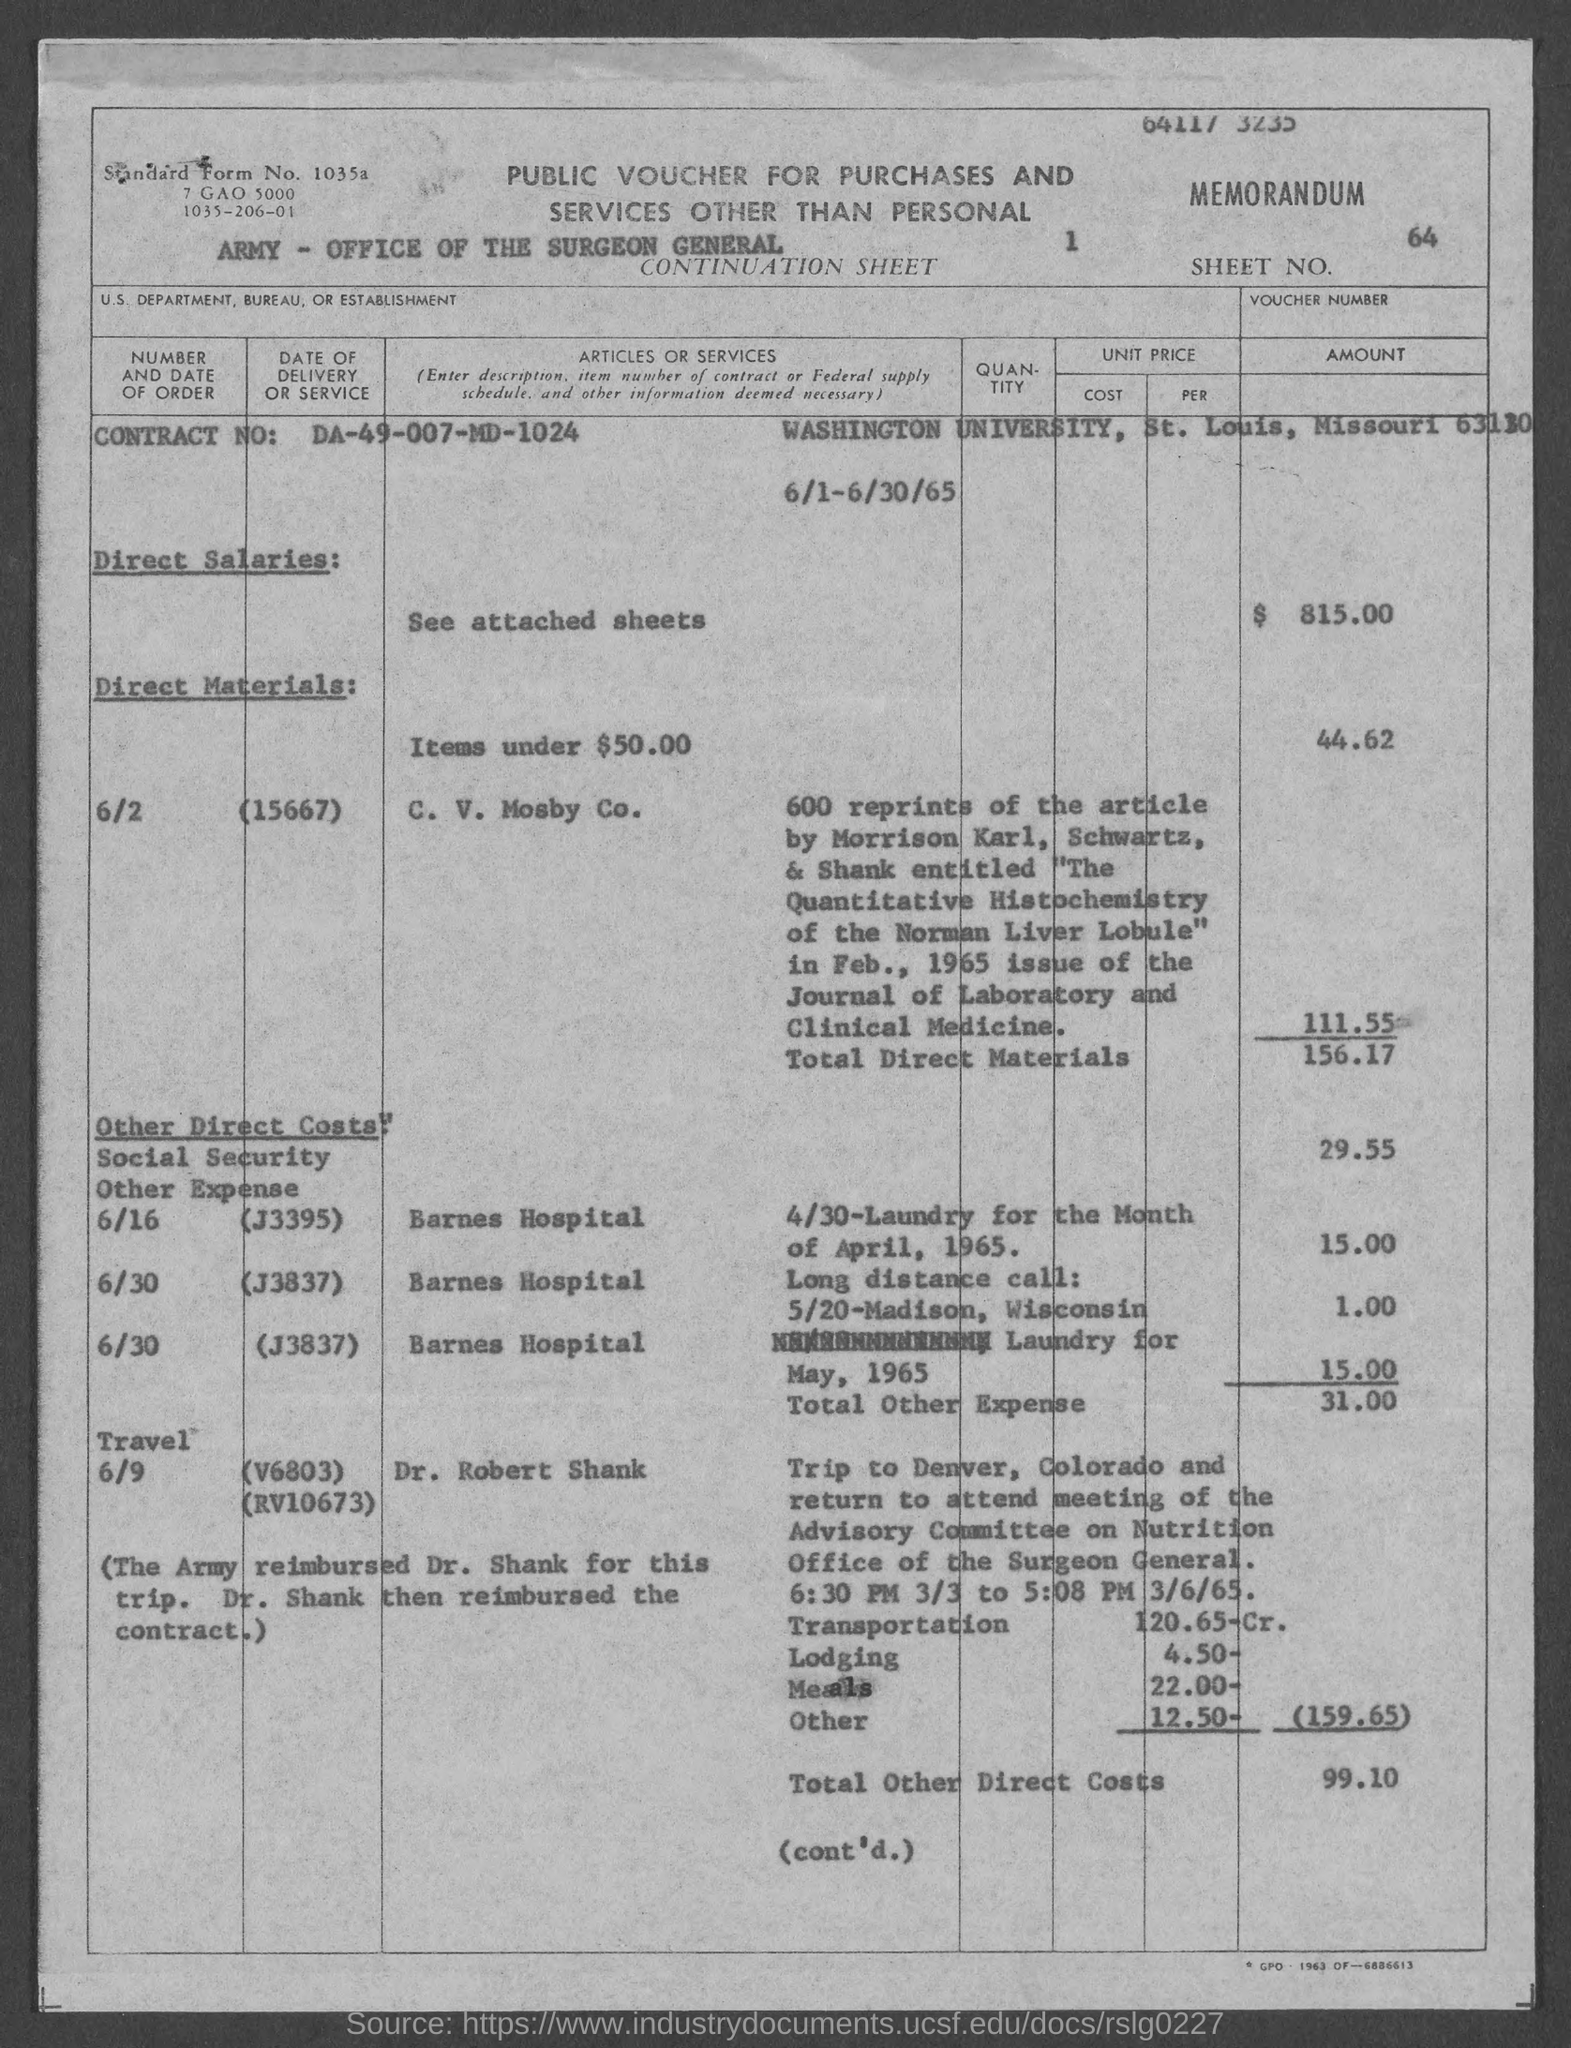Give some essential details in this illustration. The Contract Number is DA-49-007-MD-1024. The direct salaries are $815.00. The total direct materials is 156.17... The total Other Direct Costs is $99.10. The total other expense is $31.00. 